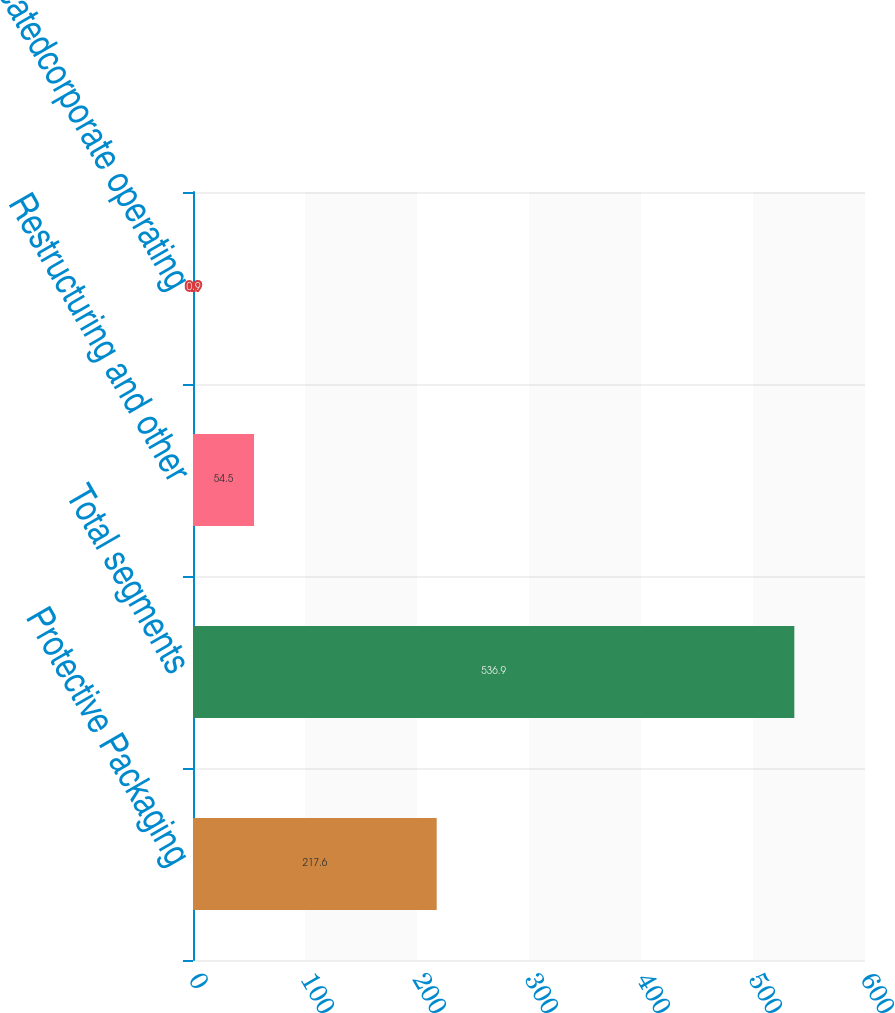Convert chart. <chart><loc_0><loc_0><loc_500><loc_500><bar_chart><fcel>Protective Packaging<fcel>Total segments<fcel>Restructuring and other<fcel>Unallocatedcorporate operating<nl><fcel>217.6<fcel>536.9<fcel>54.5<fcel>0.9<nl></chart> 